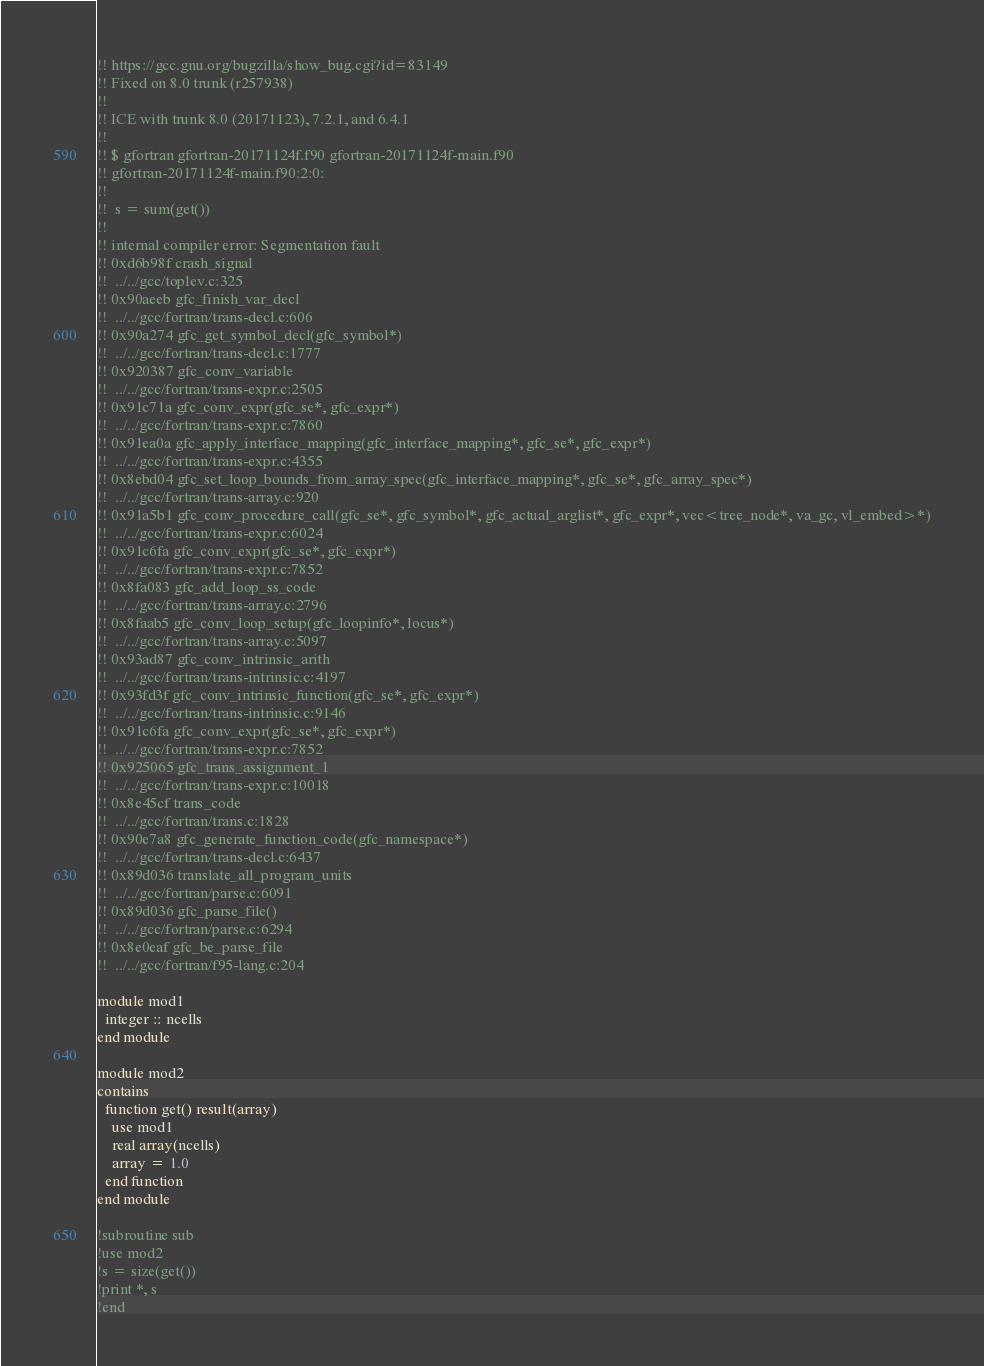Convert code to text. <code><loc_0><loc_0><loc_500><loc_500><_FORTRAN_>!! https://gcc.gnu.org/bugzilla/show_bug.cgi?id=83149
!! Fixed on 8.0 trunk (r257938)
!!
!! ICE with trunk 8.0 (20171123), 7.2.1, and 6.4.1
!!
!! $ gfortran gfortran-20171124f.f90 gfortran-20171124f-main.f90 
!! gfortran-20171124f-main.f90:2:0:
!! 
!!  s = sum(get())
!!  
!! internal compiler error: Segmentation fault
!! 0xd6b98f crash_signal
!! 	../../gcc/toplev.c:325
!! 0x90aeeb gfc_finish_var_decl
!! 	../../gcc/fortran/trans-decl.c:606
!! 0x90a274 gfc_get_symbol_decl(gfc_symbol*)
!! 	../../gcc/fortran/trans-decl.c:1777
!! 0x920387 gfc_conv_variable
!! 	../../gcc/fortran/trans-expr.c:2505
!! 0x91c71a gfc_conv_expr(gfc_se*, gfc_expr*)
!! 	../../gcc/fortran/trans-expr.c:7860
!! 0x91ea0a gfc_apply_interface_mapping(gfc_interface_mapping*, gfc_se*, gfc_expr*)
!! 	../../gcc/fortran/trans-expr.c:4355
!! 0x8ebd04 gfc_set_loop_bounds_from_array_spec(gfc_interface_mapping*, gfc_se*, gfc_array_spec*)
!! 	../../gcc/fortran/trans-array.c:920
!! 0x91a5b1 gfc_conv_procedure_call(gfc_se*, gfc_symbol*, gfc_actual_arglist*, gfc_expr*, vec<tree_node*, va_gc, vl_embed>*)
!! 	../../gcc/fortran/trans-expr.c:6024
!! 0x91c6fa gfc_conv_expr(gfc_se*, gfc_expr*)
!! 	../../gcc/fortran/trans-expr.c:7852
!! 0x8fa083 gfc_add_loop_ss_code
!! 	../../gcc/fortran/trans-array.c:2796
!! 0x8faab5 gfc_conv_loop_setup(gfc_loopinfo*, locus*)
!! 	../../gcc/fortran/trans-array.c:5097
!! 0x93ad87 gfc_conv_intrinsic_arith
!! 	../../gcc/fortran/trans-intrinsic.c:4197
!! 0x93fd3f gfc_conv_intrinsic_function(gfc_se*, gfc_expr*)
!! 	../../gcc/fortran/trans-intrinsic.c:9146
!! 0x91c6fa gfc_conv_expr(gfc_se*, gfc_expr*)
!! 	../../gcc/fortran/trans-expr.c:7852
!! 0x925065 gfc_trans_assignment_1
!! 	../../gcc/fortran/trans-expr.c:10018
!! 0x8e45cf trans_code
!! 	../../gcc/fortran/trans.c:1828
!! 0x90e7a8 gfc_generate_function_code(gfc_namespace*)
!! 	../../gcc/fortran/trans-decl.c:6437
!! 0x89d036 translate_all_program_units
!! 	../../gcc/fortran/parse.c:6091
!! 0x89d036 gfc_parse_file()
!! 	../../gcc/fortran/parse.c:6294
!! 0x8e0eaf gfc_be_parse_file
!! 	../../gcc/fortran/f95-lang.c:204

module mod1
  integer :: ncells
end module

module mod2
contains
  function get() result(array)
    use mod1
    real array(ncells)
    array = 1.0
  end function
end module

!subroutine sub
!use mod2
!s = size(get())
!print *, s
!end
</code> 